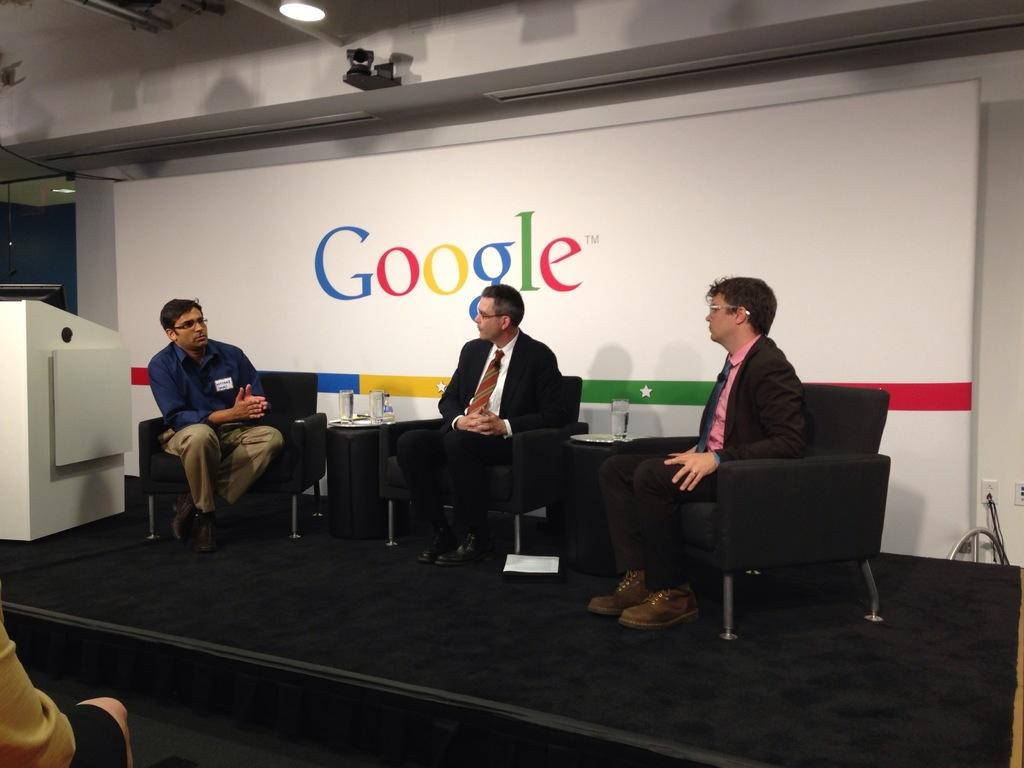How many people are on the stage in the image? There are three persons sitting on chairs on the stage. What can be seen on the tables in the image? There are glasses on the tables. What is visible in the image that provides illumination? There are lights visible in the image. What object is present on the stage for the speakers to use? There is a podium in the image. What is located in the background of the image? There is a name board in the background of the image. How many sheep are visible in the image? There are no sheep present in the image. What type of blood is visible on the podium in the image? There is no blood visible in the image, and the podium is not associated with any blood. 